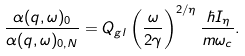<formula> <loc_0><loc_0><loc_500><loc_500>\frac { \alpha ( { q } , \omega ) _ { 0 } } { \alpha ( { q } , \omega ) _ { 0 , N } } = Q _ { g l } \left ( \frac { \omega } { 2 \gamma } \right ) ^ { 2 / \eta } \frac { \hbar { I } _ { \eta } } { m \omega _ { c } } .</formula> 